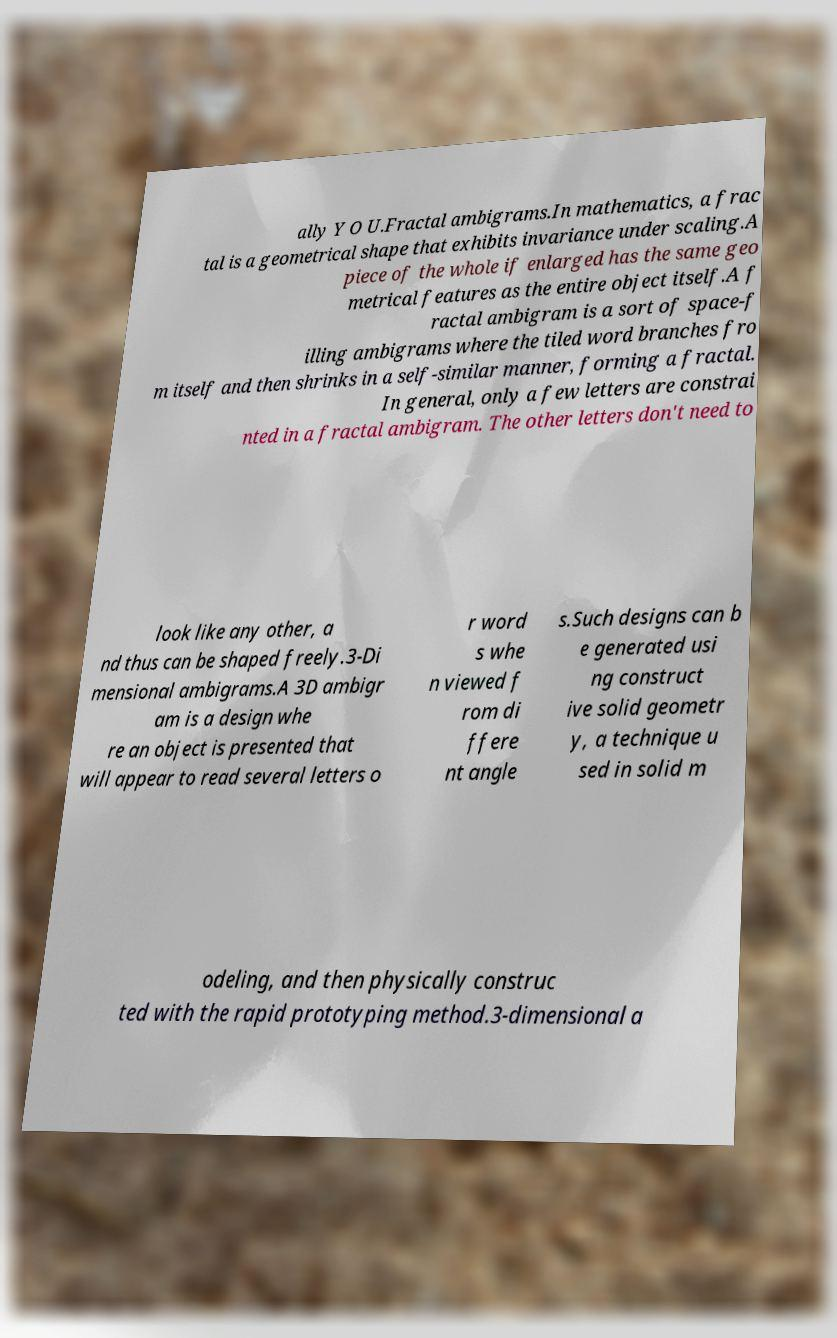There's text embedded in this image that I need extracted. Can you transcribe it verbatim? ally Y O U.Fractal ambigrams.In mathematics, a frac tal is a geometrical shape that exhibits invariance under scaling.A piece of the whole if enlarged has the same geo metrical features as the entire object itself.A f ractal ambigram is a sort of space-f illing ambigrams where the tiled word branches fro m itself and then shrinks in a self-similar manner, forming a fractal. In general, only a few letters are constrai nted in a fractal ambigram. The other letters don't need to look like any other, a nd thus can be shaped freely.3-Di mensional ambigrams.A 3D ambigr am is a design whe re an object is presented that will appear to read several letters o r word s whe n viewed f rom di ffere nt angle s.Such designs can b e generated usi ng construct ive solid geometr y, a technique u sed in solid m odeling, and then physically construc ted with the rapid prototyping method.3-dimensional a 